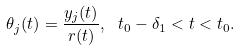Convert formula to latex. <formula><loc_0><loc_0><loc_500><loc_500>\theta _ { j } ( t ) = \frac { y _ { j } ( t ) } { r ( t ) } , \ t _ { 0 } - \delta _ { 1 } < t < t _ { 0 } .</formula> 